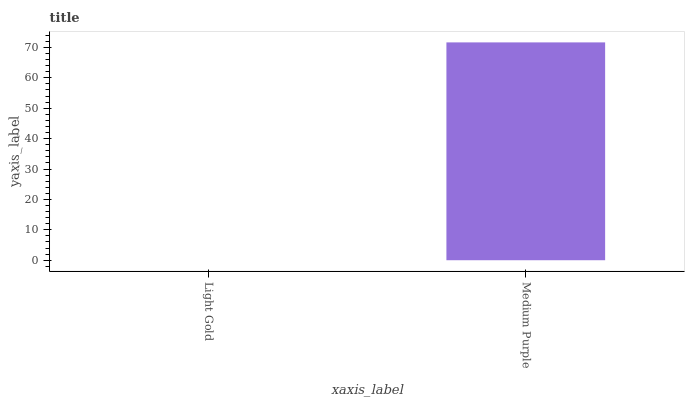Is Light Gold the minimum?
Answer yes or no. Yes. Is Medium Purple the maximum?
Answer yes or no. Yes. Is Medium Purple the minimum?
Answer yes or no. No. Is Medium Purple greater than Light Gold?
Answer yes or no. Yes. Is Light Gold less than Medium Purple?
Answer yes or no. Yes. Is Light Gold greater than Medium Purple?
Answer yes or no. No. Is Medium Purple less than Light Gold?
Answer yes or no. No. Is Medium Purple the high median?
Answer yes or no. Yes. Is Light Gold the low median?
Answer yes or no. Yes. Is Light Gold the high median?
Answer yes or no. No. Is Medium Purple the low median?
Answer yes or no. No. 